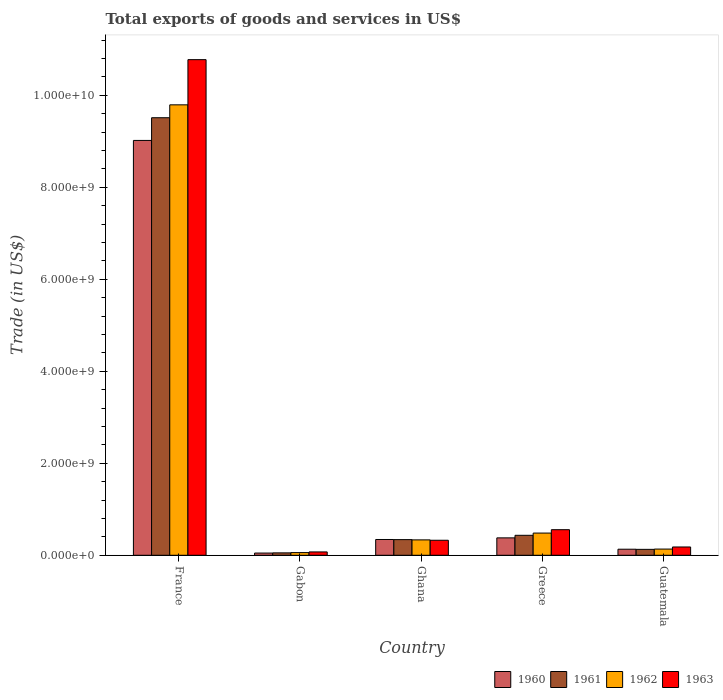How many different coloured bars are there?
Provide a succinct answer. 4. Are the number of bars on each tick of the X-axis equal?
Provide a short and direct response. Yes. In how many cases, is the number of bars for a given country not equal to the number of legend labels?
Provide a succinct answer. 0. What is the total exports of goods and services in 1960 in Ghana?
Provide a short and direct response. 3.43e+08. Across all countries, what is the maximum total exports of goods and services in 1963?
Offer a terse response. 1.08e+1. Across all countries, what is the minimum total exports of goods and services in 1963?
Offer a terse response. 7.28e+07. In which country was the total exports of goods and services in 1961 maximum?
Offer a terse response. France. In which country was the total exports of goods and services in 1962 minimum?
Provide a short and direct response. Gabon. What is the total total exports of goods and services in 1960 in the graph?
Keep it short and to the point. 9.92e+09. What is the difference between the total exports of goods and services in 1960 in Gabon and that in Guatemala?
Offer a terse response. -8.36e+07. What is the difference between the total exports of goods and services in 1961 in France and the total exports of goods and services in 1963 in Ghana?
Offer a very short reply. 9.19e+09. What is the average total exports of goods and services in 1963 per country?
Your response must be concise. 2.38e+09. What is the difference between the total exports of goods and services of/in 1963 and total exports of goods and services of/in 1960 in Guatemala?
Your answer should be very brief. 4.85e+07. What is the ratio of the total exports of goods and services in 1962 in Gabon to that in Guatemala?
Keep it short and to the point. 0.43. Is the difference between the total exports of goods and services in 1963 in Greece and Guatemala greater than the difference between the total exports of goods and services in 1960 in Greece and Guatemala?
Ensure brevity in your answer.  Yes. What is the difference between the highest and the second highest total exports of goods and services in 1963?
Give a very brief answer. -1.02e+1. What is the difference between the highest and the lowest total exports of goods and services in 1960?
Provide a short and direct response. 8.97e+09. In how many countries, is the total exports of goods and services in 1961 greater than the average total exports of goods and services in 1961 taken over all countries?
Make the answer very short. 1. Is the sum of the total exports of goods and services in 1963 in Ghana and Greece greater than the maximum total exports of goods and services in 1960 across all countries?
Your answer should be compact. No. Is it the case that in every country, the sum of the total exports of goods and services in 1961 and total exports of goods and services in 1963 is greater than the sum of total exports of goods and services in 1960 and total exports of goods and services in 1962?
Offer a very short reply. No. What does the 2nd bar from the left in Ghana represents?
Keep it short and to the point. 1961. What does the 1st bar from the right in Guatemala represents?
Keep it short and to the point. 1963. Is it the case that in every country, the sum of the total exports of goods and services in 1960 and total exports of goods and services in 1962 is greater than the total exports of goods and services in 1963?
Make the answer very short. Yes. How many bars are there?
Your answer should be very brief. 20. Are all the bars in the graph horizontal?
Offer a terse response. No. How many countries are there in the graph?
Ensure brevity in your answer.  5. What is the difference between two consecutive major ticks on the Y-axis?
Your answer should be compact. 2.00e+09. Are the values on the major ticks of Y-axis written in scientific E-notation?
Keep it short and to the point. Yes. Does the graph contain any zero values?
Provide a short and direct response. No. Does the graph contain grids?
Offer a terse response. No. Where does the legend appear in the graph?
Give a very brief answer. Bottom right. How many legend labels are there?
Ensure brevity in your answer.  4. What is the title of the graph?
Give a very brief answer. Total exports of goods and services in US$. Does "1964" appear as one of the legend labels in the graph?
Make the answer very short. No. What is the label or title of the Y-axis?
Offer a terse response. Trade (in US$). What is the Trade (in US$) of 1960 in France?
Make the answer very short. 9.02e+09. What is the Trade (in US$) of 1961 in France?
Your response must be concise. 9.51e+09. What is the Trade (in US$) in 1962 in France?
Ensure brevity in your answer.  9.79e+09. What is the Trade (in US$) of 1963 in France?
Keep it short and to the point. 1.08e+1. What is the Trade (in US$) of 1960 in Gabon?
Provide a succinct answer. 4.83e+07. What is the Trade (in US$) of 1961 in Gabon?
Offer a terse response. 5.23e+07. What is the Trade (in US$) in 1962 in Gabon?
Your response must be concise. 5.80e+07. What is the Trade (in US$) of 1963 in Gabon?
Ensure brevity in your answer.  7.28e+07. What is the Trade (in US$) in 1960 in Ghana?
Offer a terse response. 3.43e+08. What is the Trade (in US$) of 1961 in Ghana?
Give a very brief answer. 3.40e+08. What is the Trade (in US$) of 1962 in Ghana?
Keep it short and to the point. 3.35e+08. What is the Trade (in US$) of 1963 in Ghana?
Keep it short and to the point. 3.26e+08. What is the Trade (in US$) in 1960 in Greece?
Your response must be concise. 3.78e+08. What is the Trade (in US$) of 1961 in Greece?
Offer a very short reply. 4.34e+08. What is the Trade (in US$) in 1962 in Greece?
Give a very brief answer. 4.83e+08. What is the Trade (in US$) in 1963 in Greece?
Offer a very short reply. 5.56e+08. What is the Trade (in US$) in 1960 in Guatemala?
Your answer should be compact. 1.32e+08. What is the Trade (in US$) in 1961 in Guatemala?
Make the answer very short. 1.29e+08. What is the Trade (in US$) of 1962 in Guatemala?
Offer a very short reply. 1.35e+08. What is the Trade (in US$) in 1963 in Guatemala?
Ensure brevity in your answer.  1.80e+08. Across all countries, what is the maximum Trade (in US$) in 1960?
Offer a terse response. 9.02e+09. Across all countries, what is the maximum Trade (in US$) of 1961?
Provide a short and direct response. 9.51e+09. Across all countries, what is the maximum Trade (in US$) in 1962?
Your answer should be compact. 9.79e+09. Across all countries, what is the maximum Trade (in US$) of 1963?
Keep it short and to the point. 1.08e+1. Across all countries, what is the minimum Trade (in US$) in 1960?
Give a very brief answer. 4.83e+07. Across all countries, what is the minimum Trade (in US$) in 1961?
Give a very brief answer. 5.23e+07. Across all countries, what is the minimum Trade (in US$) in 1962?
Your answer should be very brief. 5.80e+07. Across all countries, what is the minimum Trade (in US$) of 1963?
Offer a very short reply. 7.28e+07. What is the total Trade (in US$) in 1960 in the graph?
Provide a short and direct response. 9.92e+09. What is the total Trade (in US$) in 1961 in the graph?
Provide a short and direct response. 1.05e+1. What is the total Trade (in US$) of 1962 in the graph?
Your answer should be very brief. 1.08e+1. What is the total Trade (in US$) of 1963 in the graph?
Ensure brevity in your answer.  1.19e+1. What is the difference between the Trade (in US$) of 1960 in France and that in Gabon?
Your answer should be compact. 8.97e+09. What is the difference between the Trade (in US$) in 1961 in France and that in Gabon?
Your response must be concise. 9.46e+09. What is the difference between the Trade (in US$) of 1962 in France and that in Gabon?
Keep it short and to the point. 9.74e+09. What is the difference between the Trade (in US$) of 1963 in France and that in Gabon?
Make the answer very short. 1.07e+1. What is the difference between the Trade (in US$) in 1960 in France and that in Ghana?
Provide a short and direct response. 8.68e+09. What is the difference between the Trade (in US$) in 1961 in France and that in Ghana?
Your answer should be compact. 9.17e+09. What is the difference between the Trade (in US$) of 1962 in France and that in Ghana?
Provide a succinct answer. 9.46e+09. What is the difference between the Trade (in US$) in 1963 in France and that in Ghana?
Provide a succinct answer. 1.04e+1. What is the difference between the Trade (in US$) of 1960 in France and that in Greece?
Provide a succinct answer. 8.64e+09. What is the difference between the Trade (in US$) of 1961 in France and that in Greece?
Provide a succinct answer. 9.08e+09. What is the difference between the Trade (in US$) in 1962 in France and that in Greece?
Your answer should be compact. 9.31e+09. What is the difference between the Trade (in US$) of 1963 in France and that in Greece?
Your response must be concise. 1.02e+1. What is the difference between the Trade (in US$) in 1960 in France and that in Guatemala?
Offer a very short reply. 8.89e+09. What is the difference between the Trade (in US$) of 1961 in France and that in Guatemala?
Make the answer very short. 9.38e+09. What is the difference between the Trade (in US$) of 1962 in France and that in Guatemala?
Your answer should be compact. 9.66e+09. What is the difference between the Trade (in US$) of 1963 in France and that in Guatemala?
Make the answer very short. 1.06e+1. What is the difference between the Trade (in US$) in 1960 in Gabon and that in Ghana?
Your answer should be very brief. -2.95e+08. What is the difference between the Trade (in US$) in 1961 in Gabon and that in Ghana?
Your answer should be compact. -2.88e+08. What is the difference between the Trade (in US$) in 1962 in Gabon and that in Ghana?
Your answer should be very brief. -2.77e+08. What is the difference between the Trade (in US$) in 1963 in Gabon and that in Ghana?
Your response must be concise. -2.54e+08. What is the difference between the Trade (in US$) in 1960 in Gabon and that in Greece?
Your answer should be compact. -3.30e+08. What is the difference between the Trade (in US$) in 1961 in Gabon and that in Greece?
Offer a terse response. -3.82e+08. What is the difference between the Trade (in US$) of 1962 in Gabon and that in Greece?
Make the answer very short. -4.25e+08. What is the difference between the Trade (in US$) of 1963 in Gabon and that in Greece?
Provide a short and direct response. -4.84e+08. What is the difference between the Trade (in US$) of 1960 in Gabon and that in Guatemala?
Give a very brief answer. -8.36e+07. What is the difference between the Trade (in US$) in 1961 in Gabon and that in Guatemala?
Give a very brief answer. -7.64e+07. What is the difference between the Trade (in US$) in 1962 in Gabon and that in Guatemala?
Your answer should be very brief. -7.68e+07. What is the difference between the Trade (in US$) of 1963 in Gabon and that in Guatemala?
Provide a short and direct response. -1.08e+08. What is the difference between the Trade (in US$) in 1960 in Ghana and that in Greece?
Offer a very short reply. -3.53e+07. What is the difference between the Trade (in US$) in 1961 in Ghana and that in Greece?
Your answer should be compact. -9.37e+07. What is the difference between the Trade (in US$) in 1962 in Ghana and that in Greece?
Provide a succinct answer. -1.48e+08. What is the difference between the Trade (in US$) of 1963 in Ghana and that in Greece?
Make the answer very short. -2.30e+08. What is the difference between the Trade (in US$) of 1960 in Ghana and that in Guatemala?
Provide a short and direct response. 2.11e+08. What is the difference between the Trade (in US$) in 1961 in Ghana and that in Guatemala?
Make the answer very short. 2.12e+08. What is the difference between the Trade (in US$) of 1962 in Ghana and that in Guatemala?
Give a very brief answer. 2.00e+08. What is the difference between the Trade (in US$) in 1963 in Ghana and that in Guatemala?
Your response must be concise. 1.46e+08. What is the difference between the Trade (in US$) of 1960 in Greece and that in Guatemala?
Keep it short and to the point. 2.47e+08. What is the difference between the Trade (in US$) in 1961 in Greece and that in Guatemala?
Offer a very short reply. 3.05e+08. What is the difference between the Trade (in US$) in 1962 in Greece and that in Guatemala?
Offer a terse response. 3.48e+08. What is the difference between the Trade (in US$) of 1963 in Greece and that in Guatemala?
Offer a terse response. 3.76e+08. What is the difference between the Trade (in US$) in 1960 in France and the Trade (in US$) in 1961 in Gabon?
Offer a terse response. 8.97e+09. What is the difference between the Trade (in US$) in 1960 in France and the Trade (in US$) in 1962 in Gabon?
Ensure brevity in your answer.  8.96e+09. What is the difference between the Trade (in US$) of 1960 in France and the Trade (in US$) of 1963 in Gabon?
Your response must be concise. 8.95e+09. What is the difference between the Trade (in US$) in 1961 in France and the Trade (in US$) in 1962 in Gabon?
Offer a terse response. 9.46e+09. What is the difference between the Trade (in US$) of 1961 in France and the Trade (in US$) of 1963 in Gabon?
Make the answer very short. 9.44e+09. What is the difference between the Trade (in US$) of 1962 in France and the Trade (in US$) of 1963 in Gabon?
Ensure brevity in your answer.  9.72e+09. What is the difference between the Trade (in US$) in 1960 in France and the Trade (in US$) in 1961 in Ghana?
Provide a short and direct response. 8.68e+09. What is the difference between the Trade (in US$) in 1960 in France and the Trade (in US$) in 1962 in Ghana?
Your response must be concise. 8.68e+09. What is the difference between the Trade (in US$) of 1960 in France and the Trade (in US$) of 1963 in Ghana?
Your answer should be compact. 8.69e+09. What is the difference between the Trade (in US$) of 1961 in France and the Trade (in US$) of 1962 in Ghana?
Offer a very short reply. 9.18e+09. What is the difference between the Trade (in US$) in 1961 in France and the Trade (in US$) in 1963 in Ghana?
Provide a succinct answer. 9.19e+09. What is the difference between the Trade (in US$) in 1962 in France and the Trade (in US$) in 1963 in Ghana?
Your answer should be very brief. 9.47e+09. What is the difference between the Trade (in US$) of 1960 in France and the Trade (in US$) of 1961 in Greece?
Your answer should be very brief. 8.59e+09. What is the difference between the Trade (in US$) in 1960 in France and the Trade (in US$) in 1962 in Greece?
Provide a short and direct response. 8.54e+09. What is the difference between the Trade (in US$) of 1960 in France and the Trade (in US$) of 1963 in Greece?
Give a very brief answer. 8.46e+09. What is the difference between the Trade (in US$) of 1961 in France and the Trade (in US$) of 1962 in Greece?
Provide a short and direct response. 9.03e+09. What is the difference between the Trade (in US$) in 1961 in France and the Trade (in US$) in 1963 in Greece?
Your response must be concise. 8.96e+09. What is the difference between the Trade (in US$) of 1962 in France and the Trade (in US$) of 1963 in Greece?
Your answer should be compact. 9.24e+09. What is the difference between the Trade (in US$) of 1960 in France and the Trade (in US$) of 1961 in Guatemala?
Your answer should be very brief. 8.89e+09. What is the difference between the Trade (in US$) in 1960 in France and the Trade (in US$) in 1962 in Guatemala?
Your answer should be very brief. 8.88e+09. What is the difference between the Trade (in US$) of 1960 in France and the Trade (in US$) of 1963 in Guatemala?
Offer a very short reply. 8.84e+09. What is the difference between the Trade (in US$) in 1961 in France and the Trade (in US$) in 1962 in Guatemala?
Your response must be concise. 9.38e+09. What is the difference between the Trade (in US$) of 1961 in France and the Trade (in US$) of 1963 in Guatemala?
Make the answer very short. 9.33e+09. What is the difference between the Trade (in US$) of 1962 in France and the Trade (in US$) of 1963 in Guatemala?
Your answer should be compact. 9.61e+09. What is the difference between the Trade (in US$) in 1960 in Gabon and the Trade (in US$) in 1961 in Ghana?
Ensure brevity in your answer.  -2.92e+08. What is the difference between the Trade (in US$) of 1960 in Gabon and the Trade (in US$) of 1962 in Ghana?
Give a very brief answer. -2.86e+08. What is the difference between the Trade (in US$) in 1960 in Gabon and the Trade (in US$) in 1963 in Ghana?
Keep it short and to the point. -2.78e+08. What is the difference between the Trade (in US$) of 1961 in Gabon and the Trade (in US$) of 1962 in Ghana?
Offer a terse response. -2.82e+08. What is the difference between the Trade (in US$) in 1961 in Gabon and the Trade (in US$) in 1963 in Ghana?
Give a very brief answer. -2.74e+08. What is the difference between the Trade (in US$) of 1962 in Gabon and the Trade (in US$) of 1963 in Ghana?
Your answer should be very brief. -2.68e+08. What is the difference between the Trade (in US$) of 1960 in Gabon and the Trade (in US$) of 1961 in Greece?
Your answer should be compact. -3.86e+08. What is the difference between the Trade (in US$) of 1960 in Gabon and the Trade (in US$) of 1962 in Greece?
Your answer should be compact. -4.34e+08. What is the difference between the Trade (in US$) of 1960 in Gabon and the Trade (in US$) of 1963 in Greece?
Your response must be concise. -5.08e+08. What is the difference between the Trade (in US$) in 1961 in Gabon and the Trade (in US$) in 1962 in Greece?
Your response must be concise. -4.30e+08. What is the difference between the Trade (in US$) in 1961 in Gabon and the Trade (in US$) in 1963 in Greece?
Provide a succinct answer. -5.04e+08. What is the difference between the Trade (in US$) of 1962 in Gabon and the Trade (in US$) of 1963 in Greece?
Provide a succinct answer. -4.98e+08. What is the difference between the Trade (in US$) of 1960 in Gabon and the Trade (in US$) of 1961 in Guatemala?
Your answer should be compact. -8.04e+07. What is the difference between the Trade (in US$) in 1960 in Gabon and the Trade (in US$) in 1962 in Guatemala?
Your response must be concise. -8.65e+07. What is the difference between the Trade (in US$) of 1960 in Gabon and the Trade (in US$) of 1963 in Guatemala?
Your answer should be compact. -1.32e+08. What is the difference between the Trade (in US$) of 1961 in Gabon and the Trade (in US$) of 1962 in Guatemala?
Your answer should be compact. -8.25e+07. What is the difference between the Trade (in US$) in 1961 in Gabon and the Trade (in US$) in 1963 in Guatemala?
Ensure brevity in your answer.  -1.28e+08. What is the difference between the Trade (in US$) of 1962 in Gabon and the Trade (in US$) of 1963 in Guatemala?
Provide a short and direct response. -1.22e+08. What is the difference between the Trade (in US$) in 1960 in Ghana and the Trade (in US$) in 1961 in Greece?
Ensure brevity in your answer.  -9.09e+07. What is the difference between the Trade (in US$) of 1960 in Ghana and the Trade (in US$) of 1962 in Greece?
Keep it short and to the point. -1.40e+08. What is the difference between the Trade (in US$) of 1960 in Ghana and the Trade (in US$) of 1963 in Greece?
Provide a short and direct response. -2.13e+08. What is the difference between the Trade (in US$) of 1961 in Ghana and the Trade (in US$) of 1962 in Greece?
Make the answer very short. -1.42e+08. What is the difference between the Trade (in US$) of 1961 in Ghana and the Trade (in US$) of 1963 in Greece?
Make the answer very short. -2.16e+08. What is the difference between the Trade (in US$) of 1962 in Ghana and the Trade (in US$) of 1963 in Greece?
Ensure brevity in your answer.  -2.22e+08. What is the difference between the Trade (in US$) in 1960 in Ghana and the Trade (in US$) in 1961 in Guatemala?
Provide a succinct answer. 2.14e+08. What is the difference between the Trade (in US$) of 1960 in Ghana and the Trade (in US$) of 1962 in Guatemala?
Make the answer very short. 2.08e+08. What is the difference between the Trade (in US$) in 1960 in Ghana and the Trade (in US$) in 1963 in Guatemala?
Give a very brief answer. 1.63e+08. What is the difference between the Trade (in US$) of 1961 in Ghana and the Trade (in US$) of 1962 in Guatemala?
Offer a terse response. 2.06e+08. What is the difference between the Trade (in US$) of 1961 in Ghana and the Trade (in US$) of 1963 in Guatemala?
Offer a very short reply. 1.60e+08. What is the difference between the Trade (in US$) in 1962 in Ghana and the Trade (in US$) in 1963 in Guatemala?
Your response must be concise. 1.54e+08. What is the difference between the Trade (in US$) in 1960 in Greece and the Trade (in US$) in 1961 in Guatemala?
Make the answer very short. 2.50e+08. What is the difference between the Trade (in US$) in 1960 in Greece and the Trade (in US$) in 1962 in Guatemala?
Offer a terse response. 2.44e+08. What is the difference between the Trade (in US$) in 1960 in Greece and the Trade (in US$) in 1963 in Guatemala?
Offer a very short reply. 1.98e+08. What is the difference between the Trade (in US$) of 1961 in Greece and the Trade (in US$) of 1962 in Guatemala?
Ensure brevity in your answer.  2.99e+08. What is the difference between the Trade (in US$) in 1961 in Greece and the Trade (in US$) in 1963 in Guatemala?
Offer a terse response. 2.54e+08. What is the difference between the Trade (in US$) of 1962 in Greece and the Trade (in US$) of 1963 in Guatemala?
Give a very brief answer. 3.02e+08. What is the average Trade (in US$) in 1960 per country?
Keep it short and to the point. 1.98e+09. What is the average Trade (in US$) of 1961 per country?
Ensure brevity in your answer.  2.09e+09. What is the average Trade (in US$) in 1962 per country?
Your response must be concise. 2.16e+09. What is the average Trade (in US$) in 1963 per country?
Give a very brief answer. 2.38e+09. What is the difference between the Trade (in US$) in 1960 and Trade (in US$) in 1961 in France?
Keep it short and to the point. -4.94e+08. What is the difference between the Trade (in US$) of 1960 and Trade (in US$) of 1962 in France?
Provide a succinct answer. -7.74e+08. What is the difference between the Trade (in US$) of 1960 and Trade (in US$) of 1963 in France?
Provide a short and direct response. -1.76e+09. What is the difference between the Trade (in US$) of 1961 and Trade (in US$) of 1962 in France?
Your answer should be compact. -2.80e+08. What is the difference between the Trade (in US$) of 1961 and Trade (in US$) of 1963 in France?
Provide a succinct answer. -1.26e+09. What is the difference between the Trade (in US$) of 1962 and Trade (in US$) of 1963 in France?
Make the answer very short. -9.82e+08. What is the difference between the Trade (in US$) of 1960 and Trade (in US$) of 1961 in Gabon?
Ensure brevity in your answer.  -3.98e+06. What is the difference between the Trade (in US$) in 1960 and Trade (in US$) in 1962 in Gabon?
Provide a short and direct response. -9.63e+06. What is the difference between the Trade (in US$) in 1960 and Trade (in US$) in 1963 in Gabon?
Offer a very short reply. -2.44e+07. What is the difference between the Trade (in US$) of 1961 and Trade (in US$) of 1962 in Gabon?
Give a very brief answer. -5.65e+06. What is the difference between the Trade (in US$) in 1961 and Trade (in US$) in 1963 in Gabon?
Offer a very short reply. -2.04e+07. What is the difference between the Trade (in US$) in 1962 and Trade (in US$) in 1963 in Gabon?
Make the answer very short. -1.48e+07. What is the difference between the Trade (in US$) in 1960 and Trade (in US$) in 1961 in Ghana?
Keep it short and to the point. 2.80e+06. What is the difference between the Trade (in US$) in 1960 and Trade (in US$) in 1962 in Ghana?
Offer a very short reply. 8.40e+06. What is the difference between the Trade (in US$) of 1960 and Trade (in US$) of 1963 in Ghana?
Provide a short and direct response. 1.68e+07. What is the difference between the Trade (in US$) in 1961 and Trade (in US$) in 1962 in Ghana?
Make the answer very short. 5.60e+06. What is the difference between the Trade (in US$) of 1961 and Trade (in US$) of 1963 in Ghana?
Make the answer very short. 1.40e+07. What is the difference between the Trade (in US$) of 1962 and Trade (in US$) of 1963 in Ghana?
Offer a terse response. 8.40e+06. What is the difference between the Trade (in US$) in 1960 and Trade (in US$) in 1961 in Greece?
Provide a succinct answer. -5.56e+07. What is the difference between the Trade (in US$) of 1960 and Trade (in US$) of 1962 in Greece?
Make the answer very short. -1.04e+08. What is the difference between the Trade (in US$) in 1960 and Trade (in US$) in 1963 in Greece?
Make the answer very short. -1.78e+08. What is the difference between the Trade (in US$) in 1961 and Trade (in US$) in 1962 in Greece?
Offer a very short reply. -4.87e+07. What is the difference between the Trade (in US$) in 1961 and Trade (in US$) in 1963 in Greece?
Give a very brief answer. -1.22e+08. What is the difference between the Trade (in US$) of 1962 and Trade (in US$) of 1963 in Greece?
Offer a very short reply. -7.35e+07. What is the difference between the Trade (in US$) in 1960 and Trade (in US$) in 1961 in Guatemala?
Ensure brevity in your answer.  3.20e+06. What is the difference between the Trade (in US$) in 1960 and Trade (in US$) in 1962 in Guatemala?
Your answer should be very brief. -2.90e+06. What is the difference between the Trade (in US$) of 1960 and Trade (in US$) of 1963 in Guatemala?
Your answer should be compact. -4.85e+07. What is the difference between the Trade (in US$) in 1961 and Trade (in US$) in 1962 in Guatemala?
Your response must be concise. -6.10e+06. What is the difference between the Trade (in US$) of 1961 and Trade (in US$) of 1963 in Guatemala?
Your answer should be very brief. -5.17e+07. What is the difference between the Trade (in US$) in 1962 and Trade (in US$) in 1963 in Guatemala?
Ensure brevity in your answer.  -4.56e+07. What is the ratio of the Trade (in US$) in 1960 in France to that in Gabon?
Offer a very short reply. 186.58. What is the ratio of the Trade (in US$) of 1961 in France to that in Gabon?
Keep it short and to the point. 181.82. What is the ratio of the Trade (in US$) of 1962 in France to that in Gabon?
Make the answer very short. 168.93. What is the ratio of the Trade (in US$) in 1963 in France to that in Gabon?
Your answer should be very brief. 148.09. What is the ratio of the Trade (in US$) of 1960 in France to that in Ghana?
Keep it short and to the point. 26.28. What is the ratio of the Trade (in US$) in 1961 in France to that in Ghana?
Keep it short and to the point. 27.95. What is the ratio of the Trade (in US$) of 1962 in France to that in Ghana?
Provide a succinct answer. 29.25. What is the ratio of the Trade (in US$) of 1963 in France to that in Ghana?
Offer a very short reply. 33.02. What is the ratio of the Trade (in US$) in 1960 in France to that in Greece?
Ensure brevity in your answer.  23.83. What is the ratio of the Trade (in US$) of 1961 in France to that in Greece?
Offer a very short reply. 21.91. What is the ratio of the Trade (in US$) of 1962 in France to that in Greece?
Provide a succinct answer. 20.28. What is the ratio of the Trade (in US$) of 1963 in France to that in Greece?
Provide a succinct answer. 19.37. What is the ratio of the Trade (in US$) of 1960 in France to that in Guatemala?
Your response must be concise. 68.38. What is the ratio of the Trade (in US$) in 1961 in France to that in Guatemala?
Ensure brevity in your answer.  73.92. What is the ratio of the Trade (in US$) in 1962 in France to that in Guatemala?
Your answer should be very brief. 72.65. What is the ratio of the Trade (in US$) in 1963 in France to that in Guatemala?
Offer a terse response. 59.73. What is the ratio of the Trade (in US$) of 1960 in Gabon to that in Ghana?
Your answer should be very brief. 0.14. What is the ratio of the Trade (in US$) of 1961 in Gabon to that in Ghana?
Give a very brief answer. 0.15. What is the ratio of the Trade (in US$) in 1962 in Gabon to that in Ghana?
Give a very brief answer. 0.17. What is the ratio of the Trade (in US$) in 1963 in Gabon to that in Ghana?
Your answer should be compact. 0.22. What is the ratio of the Trade (in US$) in 1960 in Gabon to that in Greece?
Your response must be concise. 0.13. What is the ratio of the Trade (in US$) in 1961 in Gabon to that in Greece?
Keep it short and to the point. 0.12. What is the ratio of the Trade (in US$) of 1962 in Gabon to that in Greece?
Provide a short and direct response. 0.12. What is the ratio of the Trade (in US$) in 1963 in Gabon to that in Greece?
Your answer should be very brief. 0.13. What is the ratio of the Trade (in US$) in 1960 in Gabon to that in Guatemala?
Your response must be concise. 0.37. What is the ratio of the Trade (in US$) of 1961 in Gabon to that in Guatemala?
Give a very brief answer. 0.41. What is the ratio of the Trade (in US$) of 1962 in Gabon to that in Guatemala?
Provide a short and direct response. 0.43. What is the ratio of the Trade (in US$) in 1963 in Gabon to that in Guatemala?
Make the answer very short. 0.4. What is the ratio of the Trade (in US$) of 1960 in Ghana to that in Greece?
Keep it short and to the point. 0.91. What is the ratio of the Trade (in US$) of 1961 in Ghana to that in Greece?
Your response must be concise. 0.78. What is the ratio of the Trade (in US$) of 1962 in Ghana to that in Greece?
Your response must be concise. 0.69. What is the ratio of the Trade (in US$) of 1963 in Ghana to that in Greece?
Give a very brief answer. 0.59. What is the ratio of the Trade (in US$) of 1960 in Ghana to that in Guatemala?
Give a very brief answer. 2.6. What is the ratio of the Trade (in US$) of 1961 in Ghana to that in Guatemala?
Ensure brevity in your answer.  2.64. What is the ratio of the Trade (in US$) of 1962 in Ghana to that in Guatemala?
Offer a very short reply. 2.48. What is the ratio of the Trade (in US$) in 1963 in Ghana to that in Guatemala?
Your answer should be very brief. 1.81. What is the ratio of the Trade (in US$) of 1960 in Greece to that in Guatemala?
Provide a succinct answer. 2.87. What is the ratio of the Trade (in US$) in 1961 in Greece to that in Guatemala?
Give a very brief answer. 3.37. What is the ratio of the Trade (in US$) of 1962 in Greece to that in Guatemala?
Keep it short and to the point. 3.58. What is the ratio of the Trade (in US$) of 1963 in Greece to that in Guatemala?
Provide a short and direct response. 3.08. What is the difference between the highest and the second highest Trade (in US$) in 1960?
Your answer should be compact. 8.64e+09. What is the difference between the highest and the second highest Trade (in US$) of 1961?
Your answer should be compact. 9.08e+09. What is the difference between the highest and the second highest Trade (in US$) of 1962?
Your answer should be very brief. 9.31e+09. What is the difference between the highest and the second highest Trade (in US$) of 1963?
Your answer should be compact. 1.02e+1. What is the difference between the highest and the lowest Trade (in US$) of 1960?
Offer a very short reply. 8.97e+09. What is the difference between the highest and the lowest Trade (in US$) in 1961?
Provide a short and direct response. 9.46e+09. What is the difference between the highest and the lowest Trade (in US$) of 1962?
Offer a terse response. 9.74e+09. What is the difference between the highest and the lowest Trade (in US$) of 1963?
Give a very brief answer. 1.07e+1. 